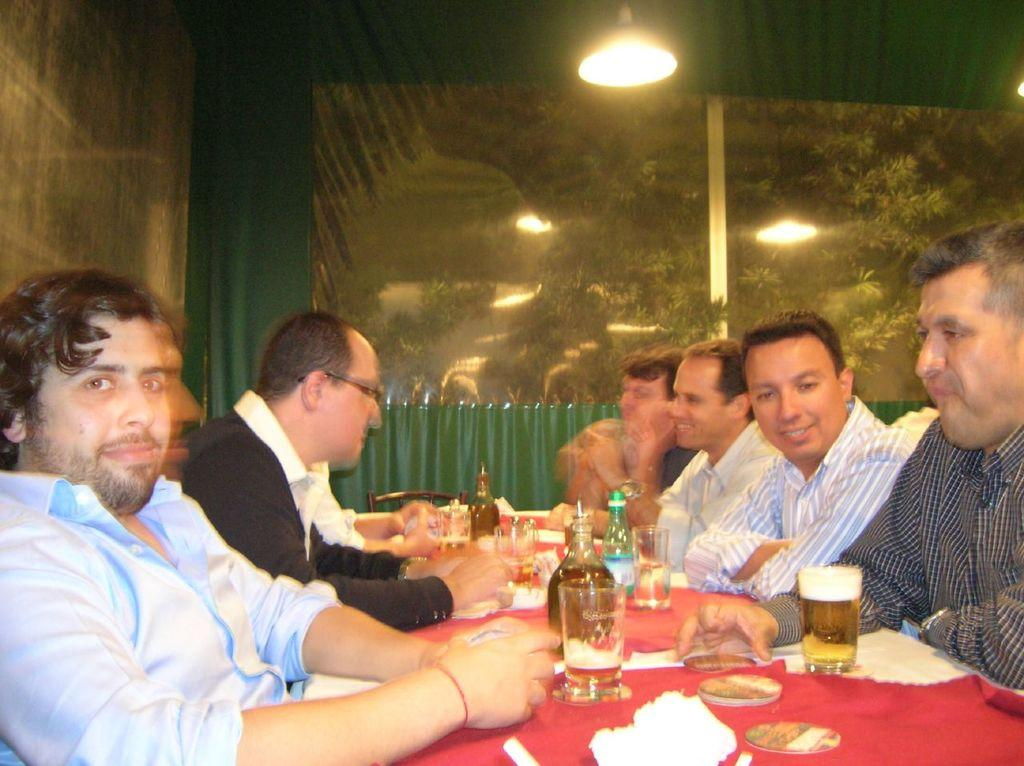What are the men in the image doing? The men in the image are sitting on chairs. What is on the table in the image? Food items, glasses, wine bottles, and a water bottle are on the table in the image. What can be seen in the background of the image? Trees, the sky, and light are visible in the background of the image. What type of pleasure can be seen on the men's faces in the image? There is no indication of pleasure on the men's faces in the image, as their expressions are not described in the provided facts. 